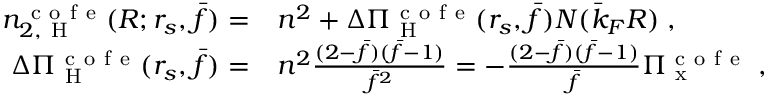Convert formula to latex. <formula><loc_0><loc_0><loc_500><loc_500>\begin{array} { r l } { n _ { 2 , H } ^ { c o f e } ( R ; r _ { s } , \bar { f } ) = } & n ^ { 2 } + \Delta \Pi _ { H } ^ { c o f e } ( r _ { s } , \bar { f } ) N ( \bar { k } _ { F } R ) \, , } \\ { \Delta \Pi _ { H } ^ { c o f e } ( r _ { s } , \bar { f } ) = } & n ^ { 2 } \frac { ( 2 - \bar { f } ) ( \bar { f } - 1 ) } { \bar { f } ^ { 2 } } = - \frac { ( 2 - \bar { f } ) ( \bar { f } - 1 ) } { \bar { f } } \Pi _ { x } ^ { c o f e } \, , } \end{array}</formula> 